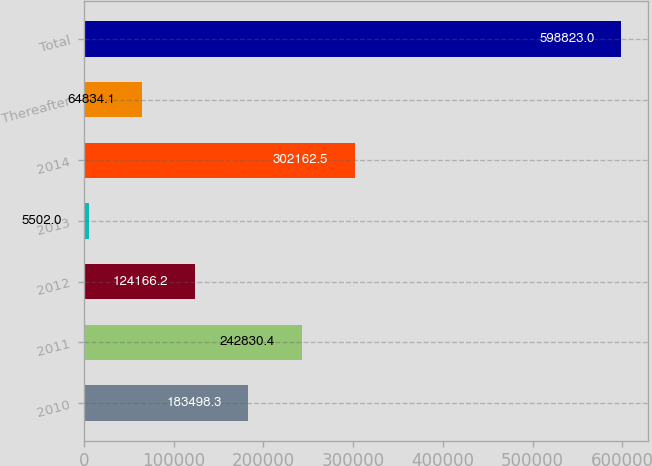Convert chart. <chart><loc_0><loc_0><loc_500><loc_500><bar_chart><fcel>2010<fcel>2011<fcel>2012<fcel>2013<fcel>2014<fcel>Thereafter<fcel>Total<nl><fcel>183498<fcel>242830<fcel>124166<fcel>5502<fcel>302162<fcel>64834.1<fcel>598823<nl></chart> 